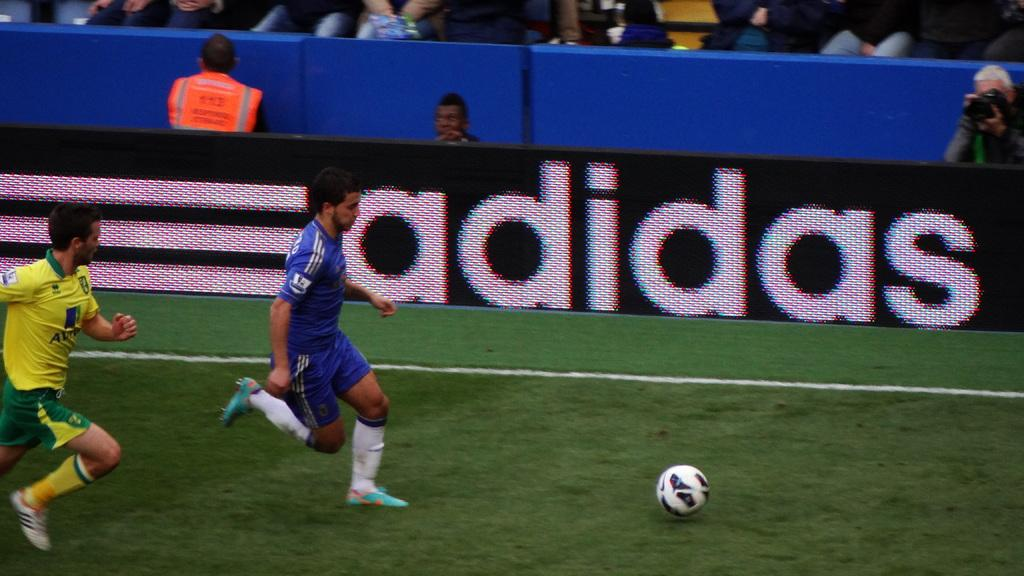Provide a one-sentence caption for the provided image. Two soccer players from opposing teams chase a soccer ball on a stadium field while the spectators look on and an adidas advertising signboard is boldly displayed in the arena. 